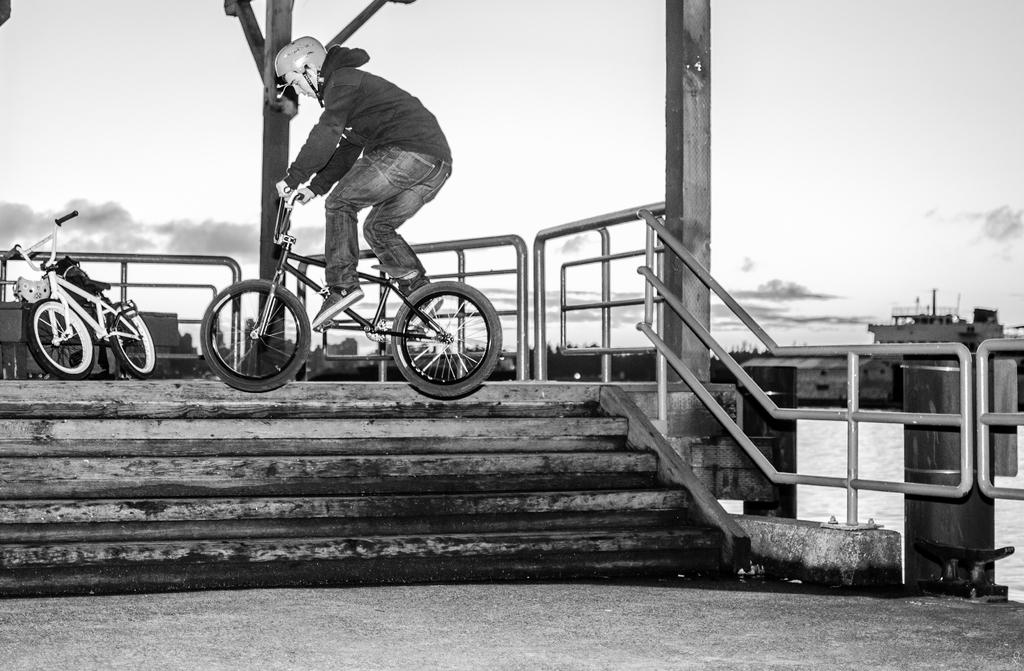What is the color scheme of the image? The image is black and white. What is the person in the image doing? The person is riding a bicycle in the image. What architectural feature can be seen in the image? There are stairs in the image. What type of barrier is present in the image? There is fencing in the image. Can you describe another bicycle in the image? Another bicycle is present behind the person riding the bicycle. What type of yoke can be seen attached to the bushes in the image? There are no yokes or bushes present in the image. What holiday is being celebrated in the image? There is no indication of a holiday being celebrated in the image. 